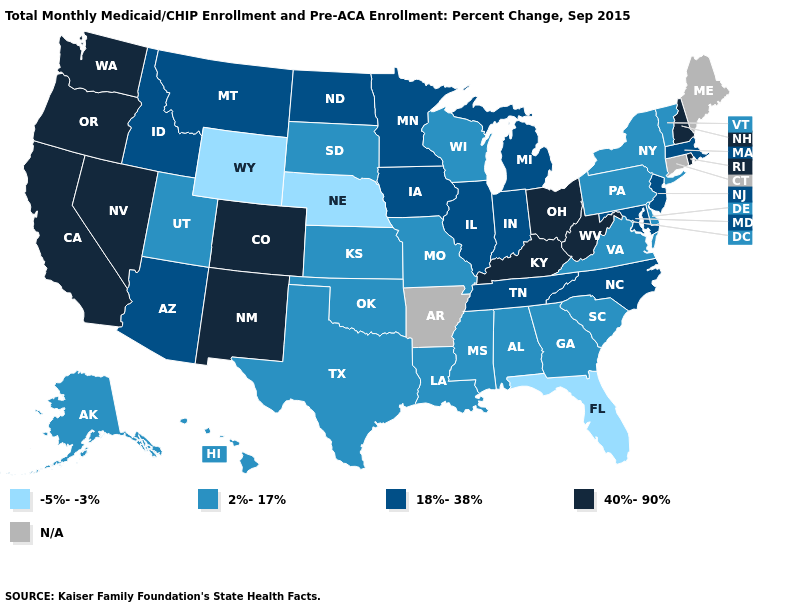What is the value of Rhode Island?
Be succinct. 40%-90%. Among the states that border Arizona , does Utah have the highest value?
Keep it brief. No. Name the states that have a value in the range -5%--3%?
Write a very short answer. Florida, Nebraska, Wyoming. Does Florida have the lowest value in the South?
Answer briefly. Yes. What is the value of Arkansas?
Write a very short answer. N/A. Does the first symbol in the legend represent the smallest category?
Write a very short answer. Yes. Does Ohio have the highest value in the USA?
Be succinct. Yes. What is the highest value in the USA?
Write a very short answer. 40%-90%. Name the states that have a value in the range 2%-17%?
Write a very short answer. Alabama, Alaska, Delaware, Georgia, Hawaii, Kansas, Louisiana, Mississippi, Missouri, New York, Oklahoma, Pennsylvania, South Carolina, South Dakota, Texas, Utah, Vermont, Virginia, Wisconsin. Name the states that have a value in the range -5%--3%?
Write a very short answer. Florida, Nebraska, Wyoming. Among the states that border Pennsylvania , does New Jersey have the highest value?
Give a very brief answer. No. What is the lowest value in the West?
Short answer required. -5%--3%. Among the states that border Kansas , which have the highest value?
Answer briefly. Colorado. What is the value of Michigan?
Short answer required. 18%-38%. Among the states that border Oklahoma , which have the lowest value?
Keep it brief. Kansas, Missouri, Texas. 